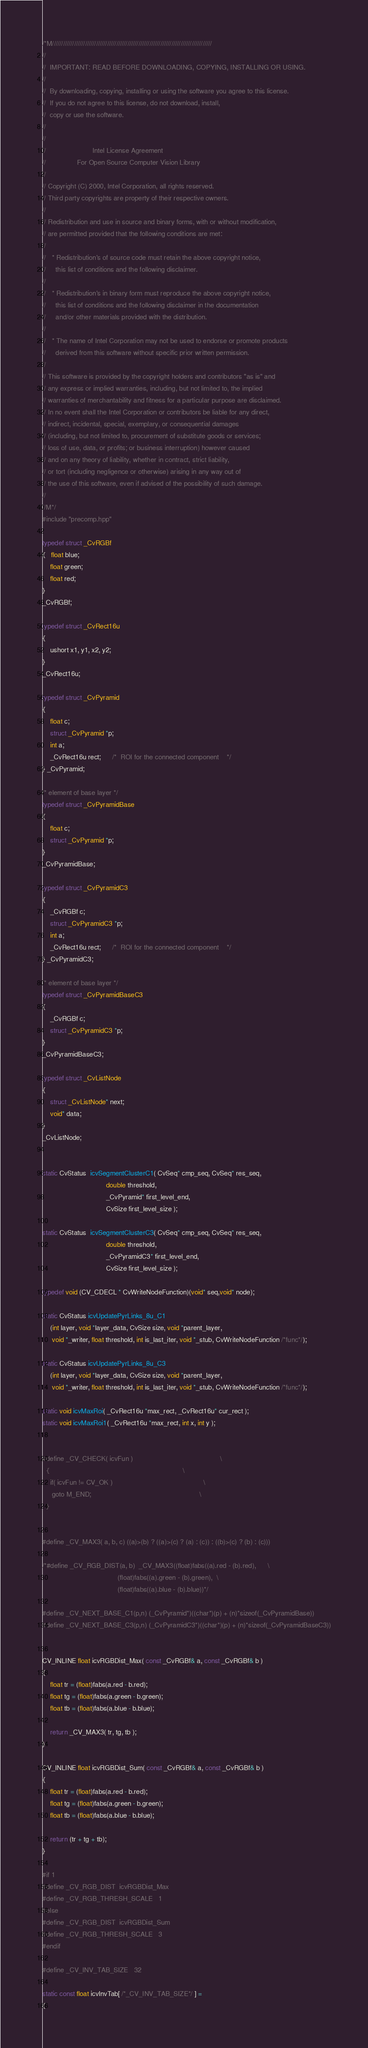<code> <loc_0><loc_0><loc_500><loc_500><_C++_>/*M///////////////////////////////////////////////////////////////////////////////////////
//
//  IMPORTANT: READ BEFORE DOWNLOADING, COPYING, INSTALLING OR USING.
//
//  By downloading, copying, installing or using the software you agree to this license.
//  If you do not agree to this license, do not download, install,
//  copy or use the software.
//
//
//                        Intel License Agreement
//                For Open Source Computer Vision Library
//
// Copyright (C) 2000, Intel Corporation, all rights reserved.
// Third party copyrights are property of their respective owners.
//
// Redistribution and use in source and binary forms, with or without modification,
// are permitted provided that the following conditions are met:
//
//   * Redistribution's of source code must retain the above copyright notice,
//     this list of conditions and the following disclaimer.
//
//   * Redistribution's in binary form must reproduce the above copyright notice,
//     this list of conditions and the following disclaimer in the documentation
//     and/or other materials provided with the distribution.
//
//   * The name of Intel Corporation may not be used to endorse or promote products
//     derived from this software without specific prior written permission.
//
// This software is provided by the copyright holders and contributors "as is" and
// any express or implied warranties, including, but not limited to, the implied
// warranties of merchantability and fitness for a particular purpose are disclaimed.
// In no event shall the Intel Corporation or contributors be liable for any direct,
// indirect, incidental, special, exemplary, or consequential damages
// (including, but not limited to, procurement of substitute goods or services;
// loss of use, data, or profits; or business interruption) however caused
// and on any theory of liability, whether in contract, strict liability,
// or tort (including negligence or otherwise) arising in any way out of
// the use of this software, even if advised of the possibility of such damage.
//
//M*/
#include "precomp.hpp"

typedef struct _CvRGBf
{   float blue;
    float green;
    float red;
}
_CvRGBf;

typedef struct _CvRect16u
{
    ushort x1, y1, x2, y2;
}
_CvRect16u;

typedef struct _CvPyramid
{
    float c;
    struct _CvPyramid *p;
    int a;
    _CvRect16u rect;      /*  ROI for the connected component    */
} _CvPyramid;

/* element of base layer */
typedef struct _CvPyramidBase
{
    float c;
    struct _CvPyramid *p;
}
_CvPyramidBase;

typedef struct _CvPyramidC3
{
    _CvRGBf c;
    struct _CvPyramidC3 *p;
    int a;
    _CvRect16u rect;      /*  ROI for the connected component    */
} _CvPyramidC3;

/* element of base layer */
typedef struct _CvPyramidBaseC3
{
    _CvRGBf c;
    struct _CvPyramidC3 *p;
}
_CvPyramidBaseC3;

typedef struct _CvListNode
{
    struct _CvListNode* next;
    void* data;
}
_CvListNode;


static CvStatus  icvSegmentClusterC1( CvSeq* cmp_seq, CvSeq* res_seq,
                                 double threshold,
                                 _CvPyramid* first_level_end,
                                 CvSize first_level_size );

static CvStatus  icvSegmentClusterC3( CvSeq* cmp_seq, CvSeq* res_seq,
                                 double threshold,
                                 _CvPyramidC3* first_level_end,
                                 CvSize first_level_size );

typedef void (CV_CDECL * CvWriteNodeFunction)(void* seq,void* node);

static CvStatus icvUpdatePyrLinks_8u_C1
    (int layer, void *layer_data, CvSize size, void *parent_layer,
     void *_writer, float threshold, int is_last_iter, void *_stub, CvWriteNodeFunction /*func*/);

static CvStatus icvUpdatePyrLinks_8u_C3
    (int layer, void *layer_data, CvSize size, void *parent_layer,
     void *_writer, float threshold, int is_last_iter, void *_stub, CvWriteNodeFunction /*func*/);

static void icvMaxRoi( _CvRect16u *max_rect, _CvRect16u* cur_rect );
static void icvMaxRoi1( _CvRect16u *max_rect, int x, int y );


#define _CV_CHECK( icvFun )                                             \
  {                                                                     \
    if( icvFun != CV_OK )                                               \
     goto M_END;                                                        \
  }


#define _CV_MAX3( a, b, c) ((a)>(b) ? ((a)>(c) ? (a) : (c)) : ((b)>(c) ? (b) : (c)))

/*#define _CV_RGB_DIST(a, b)  _CV_MAX3((float)fabs((a).red - (b).red),      \
                                       (float)fabs((a).green - (b).green),  \
                                       (float)fabs((a).blue - (b).blue))*/

#define _CV_NEXT_BASE_C1(p,n) (_CvPyramid*)((char*)(p) + (n)*sizeof(_CvPyramidBase))
#define _CV_NEXT_BASE_C3(p,n) (_CvPyramidC3*)((char*)(p) + (n)*sizeof(_CvPyramidBaseC3))


CV_INLINE float icvRGBDist_Max( const _CvRGBf& a, const _CvRGBf& b )
{
    float tr = (float)fabs(a.red - b.red);
    float tg = (float)fabs(a.green - b.green);
    float tb = (float)fabs(a.blue - b.blue);

    return _CV_MAX3( tr, tg, tb );
}

CV_INLINE float icvRGBDist_Sum( const _CvRGBf& a, const _CvRGBf& b )
{
    float tr = (float)fabs(a.red - b.red);
    float tg = (float)fabs(a.green - b.green);
    float tb = (float)fabs(a.blue - b.blue);

    return (tr + tg + tb);
}

#if 1
#define _CV_RGB_DIST  icvRGBDist_Max
#define _CV_RGB_THRESH_SCALE   1
#else
#define _CV_RGB_DIST  icvRGBDist_Sum
#define _CV_RGB_THRESH_SCALE   3
#endif

#define _CV_INV_TAB_SIZE   32

static const float icvInvTab[ /*_CV_INV_TAB_SIZE*/ ] =
{</code> 